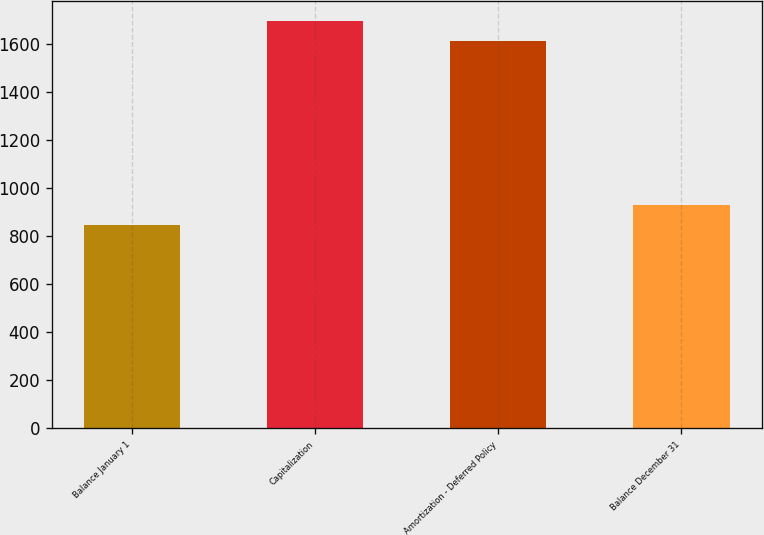Convert chart. <chart><loc_0><loc_0><loc_500><loc_500><bar_chart><fcel>Balance January 1<fcel>Capitalization<fcel>Amortization - Deferred Policy<fcel>Balance December 31<nl><fcel>847<fcel>1697.9<fcel>1613<fcel>931.9<nl></chart> 